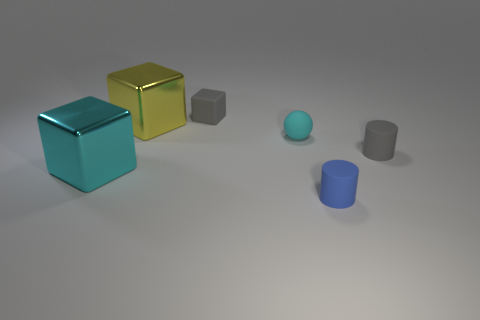Add 3 big purple matte cylinders. How many objects exist? 9 Subtract all metallic blocks. How many blocks are left? 1 Subtract all cylinders. How many objects are left? 4 Subtract all yellow blocks. How many blocks are left? 2 Subtract 0 green cubes. How many objects are left? 6 Subtract 2 cylinders. How many cylinders are left? 0 Subtract all blue blocks. Subtract all purple spheres. How many blocks are left? 3 Subtract all yellow cubes. How many gray cylinders are left? 1 Subtract all purple things. Subtract all big yellow cubes. How many objects are left? 5 Add 5 gray cylinders. How many gray cylinders are left? 6 